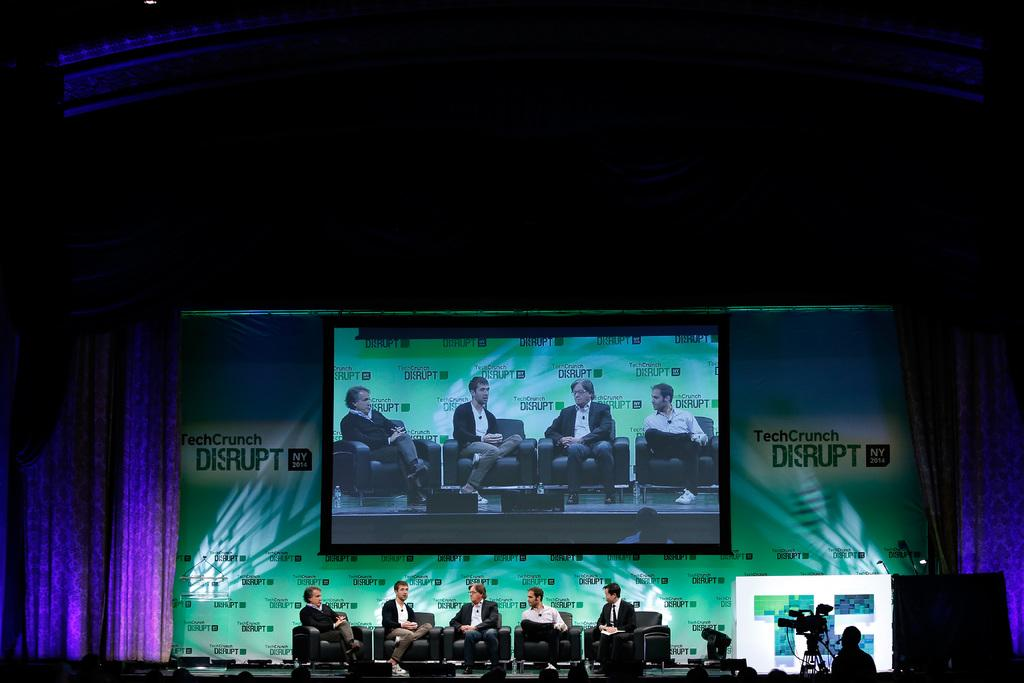<image>
Summarize the visual content of the image. a conference with several people sitting on chairs on a stage and screen that says TechCrunch Disrupt NY 2014 on the background. 